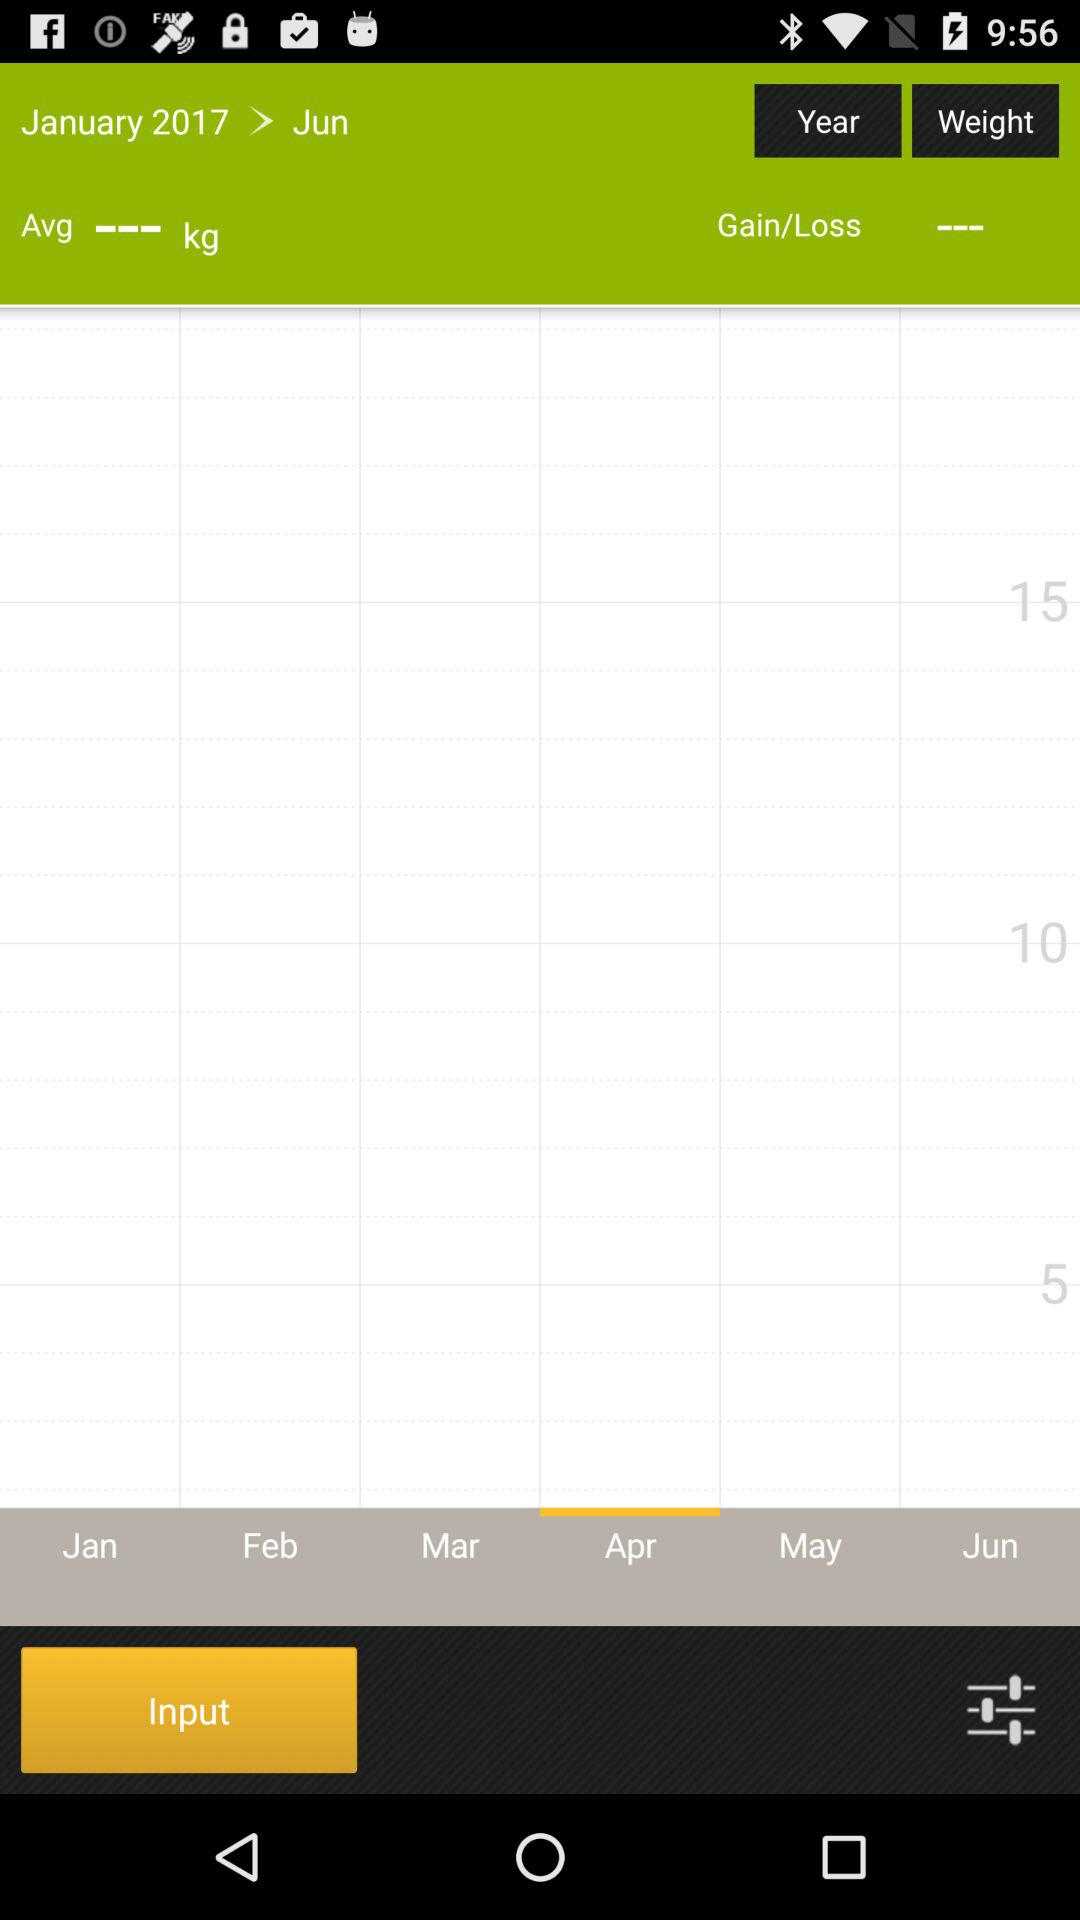How many months are included in this weight chart?
Answer the question using a single word or phrase. 6 